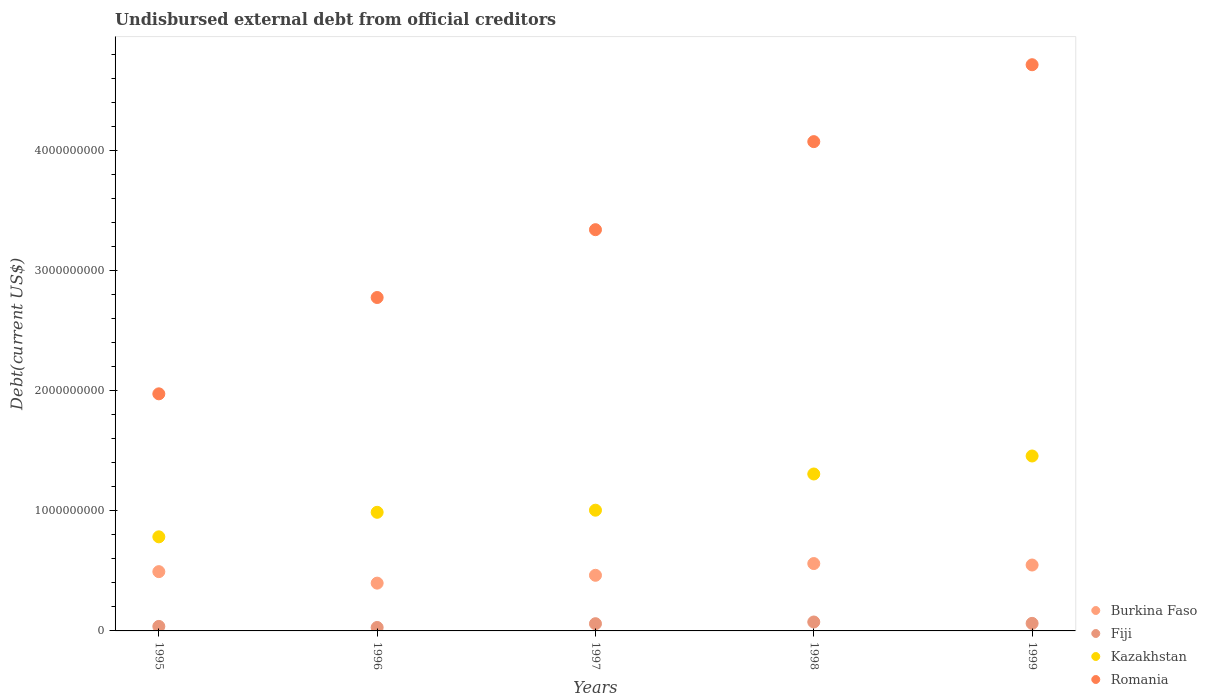How many different coloured dotlines are there?
Offer a very short reply. 4. What is the total debt in Kazakhstan in 1996?
Ensure brevity in your answer.  9.88e+08. Across all years, what is the maximum total debt in Kazakhstan?
Keep it short and to the point. 1.46e+09. Across all years, what is the minimum total debt in Kazakhstan?
Offer a terse response. 7.84e+08. In which year was the total debt in Romania minimum?
Your answer should be compact. 1995. What is the total total debt in Romania in the graph?
Your answer should be compact. 1.69e+1. What is the difference between the total debt in Romania in 1995 and that in 1996?
Keep it short and to the point. -8.02e+08. What is the difference between the total debt in Romania in 1998 and the total debt in Fiji in 1997?
Your response must be concise. 4.01e+09. What is the average total debt in Romania per year?
Make the answer very short. 3.38e+09. In the year 1997, what is the difference between the total debt in Kazakhstan and total debt in Burkina Faso?
Make the answer very short. 5.42e+08. What is the ratio of the total debt in Fiji in 1998 to that in 1999?
Your answer should be very brief. 1.18. Is the total debt in Kazakhstan in 1998 less than that in 1999?
Your answer should be compact. Yes. What is the difference between the highest and the second highest total debt in Romania?
Offer a terse response. 6.41e+08. What is the difference between the highest and the lowest total debt in Kazakhstan?
Your response must be concise. 6.73e+08. In how many years, is the total debt in Fiji greater than the average total debt in Fiji taken over all years?
Offer a very short reply. 3. Is it the case that in every year, the sum of the total debt in Romania and total debt in Fiji  is greater than the sum of total debt in Burkina Faso and total debt in Kazakhstan?
Keep it short and to the point. Yes. Does the total debt in Romania monotonically increase over the years?
Offer a very short reply. Yes. Is the total debt in Romania strictly less than the total debt in Kazakhstan over the years?
Keep it short and to the point. No. How many dotlines are there?
Make the answer very short. 4. How are the legend labels stacked?
Ensure brevity in your answer.  Vertical. What is the title of the graph?
Your response must be concise. Undisbursed external debt from official creditors. Does "Kiribati" appear as one of the legend labels in the graph?
Provide a succinct answer. No. What is the label or title of the X-axis?
Keep it short and to the point. Years. What is the label or title of the Y-axis?
Make the answer very short. Debt(current US$). What is the Debt(current US$) of Burkina Faso in 1995?
Your answer should be very brief. 4.94e+08. What is the Debt(current US$) in Fiji in 1995?
Your response must be concise. 3.75e+07. What is the Debt(current US$) of Kazakhstan in 1995?
Your answer should be compact. 7.84e+08. What is the Debt(current US$) of Romania in 1995?
Offer a very short reply. 1.97e+09. What is the Debt(current US$) of Burkina Faso in 1996?
Offer a terse response. 3.98e+08. What is the Debt(current US$) of Fiji in 1996?
Provide a succinct answer. 2.88e+07. What is the Debt(current US$) in Kazakhstan in 1996?
Make the answer very short. 9.88e+08. What is the Debt(current US$) in Romania in 1996?
Provide a short and direct response. 2.78e+09. What is the Debt(current US$) in Burkina Faso in 1997?
Your answer should be very brief. 4.63e+08. What is the Debt(current US$) of Fiji in 1997?
Offer a terse response. 6.01e+07. What is the Debt(current US$) of Kazakhstan in 1997?
Give a very brief answer. 1.01e+09. What is the Debt(current US$) in Romania in 1997?
Provide a succinct answer. 3.34e+09. What is the Debt(current US$) of Burkina Faso in 1998?
Your answer should be very brief. 5.61e+08. What is the Debt(current US$) of Fiji in 1998?
Your response must be concise. 7.43e+07. What is the Debt(current US$) in Kazakhstan in 1998?
Provide a short and direct response. 1.31e+09. What is the Debt(current US$) of Romania in 1998?
Your answer should be very brief. 4.07e+09. What is the Debt(current US$) of Burkina Faso in 1999?
Your answer should be compact. 5.49e+08. What is the Debt(current US$) in Fiji in 1999?
Provide a short and direct response. 6.29e+07. What is the Debt(current US$) in Kazakhstan in 1999?
Provide a short and direct response. 1.46e+09. What is the Debt(current US$) of Romania in 1999?
Your answer should be very brief. 4.72e+09. Across all years, what is the maximum Debt(current US$) of Burkina Faso?
Your answer should be very brief. 5.61e+08. Across all years, what is the maximum Debt(current US$) of Fiji?
Offer a very short reply. 7.43e+07. Across all years, what is the maximum Debt(current US$) in Kazakhstan?
Make the answer very short. 1.46e+09. Across all years, what is the maximum Debt(current US$) of Romania?
Ensure brevity in your answer.  4.72e+09. Across all years, what is the minimum Debt(current US$) in Burkina Faso?
Make the answer very short. 3.98e+08. Across all years, what is the minimum Debt(current US$) of Fiji?
Your response must be concise. 2.88e+07. Across all years, what is the minimum Debt(current US$) in Kazakhstan?
Offer a very short reply. 7.84e+08. Across all years, what is the minimum Debt(current US$) in Romania?
Your answer should be compact. 1.97e+09. What is the total Debt(current US$) in Burkina Faso in the graph?
Give a very brief answer. 2.46e+09. What is the total Debt(current US$) in Fiji in the graph?
Ensure brevity in your answer.  2.64e+08. What is the total Debt(current US$) in Kazakhstan in the graph?
Provide a succinct answer. 5.54e+09. What is the total Debt(current US$) in Romania in the graph?
Provide a succinct answer. 1.69e+1. What is the difference between the Debt(current US$) in Burkina Faso in 1995 and that in 1996?
Provide a short and direct response. 9.57e+07. What is the difference between the Debt(current US$) of Fiji in 1995 and that in 1996?
Give a very brief answer. 8.80e+06. What is the difference between the Debt(current US$) in Kazakhstan in 1995 and that in 1996?
Provide a short and direct response. -2.04e+08. What is the difference between the Debt(current US$) in Romania in 1995 and that in 1996?
Make the answer very short. -8.02e+08. What is the difference between the Debt(current US$) in Burkina Faso in 1995 and that in 1997?
Provide a short and direct response. 3.04e+07. What is the difference between the Debt(current US$) of Fiji in 1995 and that in 1997?
Your response must be concise. -2.26e+07. What is the difference between the Debt(current US$) in Kazakhstan in 1995 and that in 1997?
Offer a terse response. -2.22e+08. What is the difference between the Debt(current US$) of Romania in 1995 and that in 1997?
Provide a succinct answer. -1.37e+09. What is the difference between the Debt(current US$) of Burkina Faso in 1995 and that in 1998?
Keep it short and to the point. -6.73e+07. What is the difference between the Debt(current US$) of Fiji in 1995 and that in 1998?
Give a very brief answer. -3.68e+07. What is the difference between the Debt(current US$) of Kazakhstan in 1995 and that in 1998?
Ensure brevity in your answer.  -5.23e+08. What is the difference between the Debt(current US$) of Romania in 1995 and that in 1998?
Provide a succinct answer. -2.10e+09. What is the difference between the Debt(current US$) of Burkina Faso in 1995 and that in 1999?
Make the answer very short. -5.50e+07. What is the difference between the Debt(current US$) in Fiji in 1995 and that in 1999?
Provide a short and direct response. -2.53e+07. What is the difference between the Debt(current US$) of Kazakhstan in 1995 and that in 1999?
Ensure brevity in your answer.  -6.73e+08. What is the difference between the Debt(current US$) in Romania in 1995 and that in 1999?
Provide a succinct answer. -2.74e+09. What is the difference between the Debt(current US$) of Burkina Faso in 1996 and that in 1997?
Your answer should be very brief. -6.53e+07. What is the difference between the Debt(current US$) in Fiji in 1996 and that in 1997?
Make the answer very short. -3.14e+07. What is the difference between the Debt(current US$) in Kazakhstan in 1996 and that in 1997?
Provide a short and direct response. -1.75e+07. What is the difference between the Debt(current US$) in Romania in 1996 and that in 1997?
Make the answer very short. -5.65e+08. What is the difference between the Debt(current US$) of Burkina Faso in 1996 and that in 1998?
Provide a short and direct response. -1.63e+08. What is the difference between the Debt(current US$) of Fiji in 1996 and that in 1998?
Provide a succinct answer. -4.56e+07. What is the difference between the Debt(current US$) of Kazakhstan in 1996 and that in 1998?
Provide a succinct answer. -3.19e+08. What is the difference between the Debt(current US$) of Romania in 1996 and that in 1998?
Ensure brevity in your answer.  -1.30e+09. What is the difference between the Debt(current US$) of Burkina Faso in 1996 and that in 1999?
Your answer should be compact. -1.51e+08. What is the difference between the Debt(current US$) of Fiji in 1996 and that in 1999?
Ensure brevity in your answer.  -3.41e+07. What is the difference between the Debt(current US$) in Kazakhstan in 1996 and that in 1999?
Ensure brevity in your answer.  -4.69e+08. What is the difference between the Debt(current US$) in Romania in 1996 and that in 1999?
Keep it short and to the point. -1.94e+09. What is the difference between the Debt(current US$) in Burkina Faso in 1997 and that in 1998?
Your answer should be compact. -9.77e+07. What is the difference between the Debt(current US$) of Fiji in 1997 and that in 1998?
Offer a very short reply. -1.42e+07. What is the difference between the Debt(current US$) of Kazakhstan in 1997 and that in 1998?
Make the answer very short. -3.02e+08. What is the difference between the Debt(current US$) in Romania in 1997 and that in 1998?
Provide a succinct answer. -7.33e+08. What is the difference between the Debt(current US$) of Burkina Faso in 1997 and that in 1999?
Make the answer very short. -8.54e+07. What is the difference between the Debt(current US$) of Fiji in 1997 and that in 1999?
Ensure brevity in your answer.  -2.77e+06. What is the difference between the Debt(current US$) of Kazakhstan in 1997 and that in 1999?
Keep it short and to the point. -4.51e+08. What is the difference between the Debt(current US$) of Romania in 1997 and that in 1999?
Give a very brief answer. -1.37e+09. What is the difference between the Debt(current US$) in Burkina Faso in 1998 and that in 1999?
Keep it short and to the point. 1.23e+07. What is the difference between the Debt(current US$) in Fiji in 1998 and that in 1999?
Your answer should be very brief. 1.14e+07. What is the difference between the Debt(current US$) in Kazakhstan in 1998 and that in 1999?
Give a very brief answer. -1.50e+08. What is the difference between the Debt(current US$) of Romania in 1998 and that in 1999?
Offer a terse response. -6.41e+08. What is the difference between the Debt(current US$) in Burkina Faso in 1995 and the Debt(current US$) in Fiji in 1996?
Ensure brevity in your answer.  4.65e+08. What is the difference between the Debt(current US$) of Burkina Faso in 1995 and the Debt(current US$) of Kazakhstan in 1996?
Your answer should be very brief. -4.94e+08. What is the difference between the Debt(current US$) in Burkina Faso in 1995 and the Debt(current US$) in Romania in 1996?
Offer a terse response. -2.28e+09. What is the difference between the Debt(current US$) of Fiji in 1995 and the Debt(current US$) of Kazakhstan in 1996?
Your response must be concise. -9.50e+08. What is the difference between the Debt(current US$) of Fiji in 1995 and the Debt(current US$) of Romania in 1996?
Provide a short and direct response. -2.74e+09. What is the difference between the Debt(current US$) of Kazakhstan in 1995 and the Debt(current US$) of Romania in 1996?
Your answer should be very brief. -1.99e+09. What is the difference between the Debt(current US$) in Burkina Faso in 1995 and the Debt(current US$) in Fiji in 1997?
Ensure brevity in your answer.  4.34e+08. What is the difference between the Debt(current US$) in Burkina Faso in 1995 and the Debt(current US$) in Kazakhstan in 1997?
Make the answer very short. -5.12e+08. What is the difference between the Debt(current US$) of Burkina Faso in 1995 and the Debt(current US$) of Romania in 1997?
Ensure brevity in your answer.  -2.85e+09. What is the difference between the Debt(current US$) of Fiji in 1995 and the Debt(current US$) of Kazakhstan in 1997?
Keep it short and to the point. -9.68e+08. What is the difference between the Debt(current US$) of Fiji in 1995 and the Debt(current US$) of Romania in 1997?
Your response must be concise. -3.30e+09. What is the difference between the Debt(current US$) in Kazakhstan in 1995 and the Debt(current US$) in Romania in 1997?
Give a very brief answer. -2.56e+09. What is the difference between the Debt(current US$) of Burkina Faso in 1995 and the Debt(current US$) of Fiji in 1998?
Your response must be concise. 4.19e+08. What is the difference between the Debt(current US$) in Burkina Faso in 1995 and the Debt(current US$) in Kazakhstan in 1998?
Your answer should be compact. -8.13e+08. What is the difference between the Debt(current US$) of Burkina Faso in 1995 and the Debt(current US$) of Romania in 1998?
Your answer should be very brief. -3.58e+09. What is the difference between the Debt(current US$) of Fiji in 1995 and the Debt(current US$) of Kazakhstan in 1998?
Provide a short and direct response. -1.27e+09. What is the difference between the Debt(current US$) in Fiji in 1995 and the Debt(current US$) in Romania in 1998?
Keep it short and to the point. -4.04e+09. What is the difference between the Debt(current US$) in Kazakhstan in 1995 and the Debt(current US$) in Romania in 1998?
Your response must be concise. -3.29e+09. What is the difference between the Debt(current US$) of Burkina Faso in 1995 and the Debt(current US$) of Fiji in 1999?
Your answer should be compact. 4.31e+08. What is the difference between the Debt(current US$) of Burkina Faso in 1995 and the Debt(current US$) of Kazakhstan in 1999?
Make the answer very short. -9.63e+08. What is the difference between the Debt(current US$) in Burkina Faso in 1995 and the Debt(current US$) in Romania in 1999?
Your response must be concise. -4.22e+09. What is the difference between the Debt(current US$) in Fiji in 1995 and the Debt(current US$) in Kazakhstan in 1999?
Your answer should be very brief. -1.42e+09. What is the difference between the Debt(current US$) in Fiji in 1995 and the Debt(current US$) in Romania in 1999?
Your answer should be very brief. -4.68e+09. What is the difference between the Debt(current US$) of Kazakhstan in 1995 and the Debt(current US$) of Romania in 1999?
Ensure brevity in your answer.  -3.93e+09. What is the difference between the Debt(current US$) of Burkina Faso in 1996 and the Debt(current US$) of Fiji in 1997?
Ensure brevity in your answer.  3.38e+08. What is the difference between the Debt(current US$) of Burkina Faso in 1996 and the Debt(current US$) of Kazakhstan in 1997?
Give a very brief answer. -6.07e+08. What is the difference between the Debt(current US$) in Burkina Faso in 1996 and the Debt(current US$) in Romania in 1997?
Your response must be concise. -2.94e+09. What is the difference between the Debt(current US$) of Fiji in 1996 and the Debt(current US$) of Kazakhstan in 1997?
Keep it short and to the point. -9.77e+08. What is the difference between the Debt(current US$) of Fiji in 1996 and the Debt(current US$) of Romania in 1997?
Provide a short and direct response. -3.31e+09. What is the difference between the Debt(current US$) in Kazakhstan in 1996 and the Debt(current US$) in Romania in 1997?
Your answer should be very brief. -2.35e+09. What is the difference between the Debt(current US$) in Burkina Faso in 1996 and the Debt(current US$) in Fiji in 1998?
Provide a short and direct response. 3.24e+08. What is the difference between the Debt(current US$) in Burkina Faso in 1996 and the Debt(current US$) in Kazakhstan in 1998?
Your answer should be very brief. -9.09e+08. What is the difference between the Debt(current US$) in Burkina Faso in 1996 and the Debt(current US$) in Romania in 1998?
Your response must be concise. -3.68e+09. What is the difference between the Debt(current US$) of Fiji in 1996 and the Debt(current US$) of Kazakhstan in 1998?
Your answer should be very brief. -1.28e+09. What is the difference between the Debt(current US$) in Fiji in 1996 and the Debt(current US$) in Romania in 1998?
Provide a short and direct response. -4.05e+09. What is the difference between the Debt(current US$) of Kazakhstan in 1996 and the Debt(current US$) of Romania in 1998?
Ensure brevity in your answer.  -3.09e+09. What is the difference between the Debt(current US$) of Burkina Faso in 1996 and the Debt(current US$) of Fiji in 1999?
Ensure brevity in your answer.  3.35e+08. What is the difference between the Debt(current US$) in Burkina Faso in 1996 and the Debt(current US$) in Kazakhstan in 1999?
Your response must be concise. -1.06e+09. What is the difference between the Debt(current US$) of Burkina Faso in 1996 and the Debt(current US$) of Romania in 1999?
Your answer should be compact. -4.32e+09. What is the difference between the Debt(current US$) in Fiji in 1996 and the Debt(current US$) in Kazakhstan in 1999?
Make the answer very short. -1.43e+09. What is the difference between the Debt(current US$) in Fiji in 1996 and the Debt(current US$) in Romania in 1999?
Your answer should be very brief. -4.69e+09. What is the difference between the Debt(current US$) of Kazakhstan in 1996 and the Debt(current US$) of Romania in 1999?
Offer a terse response. -3.73e+09. What is the difference between the Debt(current US$) in Burkina Faso in 1997 and the Debt(current US$) in Fiji in 1998?
Provide a short and direct response. 3.89e+08. What is the difference between the Debt(current US$) of Burkina Faso in 1997 and the Debt(current US$) of Kazakhstan in 1998?
Your response must be concise. -8.44e+08. What is the difference between the Debt(current US$) of Burkina Faso in 1997 and the Debt(current US$) of Romania in 1998?
Your answer should be compact. -3.61e+09. What is the difference between the Debt(current US$) in Fiji in 1997 and the Debt(current US$) in Kazakhstan in 1998?
Your answer should be compact. -1.25e+09. What is the difference between the Debt(current US$) of Fiji in 1997 and the Debt(current US$) of Romania in 1998?
Keep it short and to the point. -4.01e+09. What is the difference between the Debt(current US$) of Kazakhstan in 1997 and the Debt(current US$) of Romania in 1998?
Your answer should be compact. -3.07e+09. What is the difference between the Debt(current US$) in Burkina Faso in 1997 and the Debt(current US$) in Fiji in 1999?
Give a very brief answer. 4.00e+08. What is the difference between the Debt(current US$) in Burkina Faso in 1997 and the Debt(current US$) in Kazakhstan in 1999?
Offer a terse response. -9.94e+08. What is the difference between the Debt(current US$) in Burkina Faso in 1997 and the Debt(current US$) in Romania in 1999?
Your answer should be very brief. -4.25e+09. What is the difference between the Debt(current US$) in Fiji in 1997 and the Debt(current US$) in Kazakhstan in 1999?
Provide a succinct answer. -1.40e+09. What is the difference between the Debt(current US$) in Fiji in 1997 and the Debt(current US$) in Romania in 1999?
Offer a very short reply. -4.66e+09. What is the difference between the Debt(current US$) in Kazakhstan in 1997 and the Debt(current US$) in Romania in 1999?
Offer a very short reply. -3.71e+09. What is the difference between the Debt(current US$) of Burkina Faso in 1998 and the Debt(current US$) of Fiji in 1999?
Offer a terse response. 4.98e+08. What is the difference between the Debt(current US$) of Burkina Faso in 1998 and the Debt(current US$) of Kazakhstan in 1999?
Your answer should be very brief. -8.96e+08. What is the difference between the Debt(current US$) in Burkina Faso in 1998 and the Debt(current US$) in Romania in 1999?
Give a very brief answer. -4.15e+09. What is the difference between the Debt(current US$) of Fiji in 1998 and the Debt(current US$) of Kazakhstan in 1999?
Make the answer very short. -1.38e+09. What is the difference between the Debt(current US$) in Fiji in 1998 and the Debt(current US$) in Romania in 1999?
Provide a succinct answer. -4.64e+09. What is the difference between the Debt(current US$) of Kazakhstan in 1998 and the Debt(current US$) of Romania in 1999?
Your answer should be very brief. -3.41e+09. What is the average Debt(current US$) in Burkina Faso per year?
Your answer should be very brief. 4.93e+08. What is the average Debt(current US$) of Fiji per year?
Provide a short and direct response. 5.27e+07. What is the average Debt(current US$) of Kazakhstan per year?
Ensure brevity in your answer.  1.11e+09. What is the average Debt(current US$) in Romania per year?
Keep it short and to the point. 3.38e+09. In the year 1995, what is the difference between the Debt(current US$) in Burkina Faso and Debt(current US$) in Fiji?
Keep it short and to the point. 4.56e+08. In the year 1995, what is the difference between the Debt(current US$) in Burkina Faso and Debt(current US$) in Kazakhstan?
Your response must be concise. -2.90e+08. In the year 1995, what is the difference between the Debt(current US$) in Burkina Faso and Debt(current US$) in Romania?
Provide a short and direct response. -1.48e+09. In the year 1995, what is the difference between the Debt(current US$) of Fiji and Debt(current US$) of Kazakhstan?
Make the answer very short. -7.46e+08. In the year 1995, what is the difference between the Debt(current US$) in Fiji and Debt(current US$) in Romania?
Provide a short and direct response. -1.94e+09. In the year 1995, what is the difference between the Debt(current US$) in Kazakhstan and Debt(current US$) in Romania?
Your answer should be very brief. -1.19e+09. In the year 1996, what is the difference between the Debt(current US$) of Burkina Faso and Debt(current US$) of Fiji?
Keep it short and to the point. 3.69e+08. In the year 1996, what is the difference between the Debt(current US$) in Burkina Faso and Debt(current US$) in Kazakhstan?
Keep it short and to the point. -5.90e+08. In the year 1996, what is the difference between the Debt(current US$) of Burkina Faso and Debt(current US$) of Romania?
Give a very brief answer. -2.38e+09. In the year 1996, what is the difference between the Debt(current US$) in Fiji and Debt(current US$) in Kazakhstan?
Give a very brief answer. -9.59e+08. In the year 1996, what is the difference between the Debt(current US$) in Fiji and Debt(current US$) in Romania?
Offer a very short reply. -2.75e+09. In the year 1996, what is the difference between the Debt(current US$) in Kazakhstan and Debt(current US$) in Romania?
Your answer should be compact. -1.79e+09. In the year 1997, what is the difference between the Debt(current US$) in Burkina Faso and Debt(current US$) in Fiji?
Offer a terse response. 4.03e+08. In the year 1997, what is the difference between the Debt(current US$) in Burkina Faso and Debt(current US$) in Kazakhstan?
Your answer should be compact. -5.42e+08. In the year 1997, what is the difference between the Debt(current US$) of Burkina Faso and Debt(current US$) of Romania?
Offer a terse response. -2.88e+09. In the year 1997, what is the difference between the Debt(current US$) of Fiji and Debt(current US$) of Kazakhstan?
Give a very brief answer. -9.45e+08. In the year 1997, what is the difference between the Debt(current US$) in Fiji and Debt(current US$) in Romania?
Provide a succinct answer. -3.28e+09. In the year 1997, what is the difference between the Debt(current US$) of Kazakhstan and Debt(current US$) of Romania?
Your response must be concise. -2.34e+09. In the year 1998, what is the difference between the Debt(current US$) in Burkina Faso and Debt(current US$) in Fiji?
Offer a very short reply. 4.87e+08. In the year 1998, what is the difference between the Debt(current US$) in Burkina Faso and Debt(current US$) in Kazakhstan?
Ensure brevity in your answer.  -7.46e+08. In the year 1998, what is the difference between the Debt(current US$) of Burkina Faso and Debt(current US$) of Romania?
Make the answer very short. -3.51e+09. In the year 1998, what is the difference between the Debt(current US$) in Fiji and Debt(current US$) in Kazakhstan?
Make the answer very short. -1.23e+09. In the year 1998, what is the difference between the Debt(current US$) in Fiji and Debt(current US$) in Romania?
Provide a short and direct response. -4.00e+09. In the year 1998, what is the difference between the Debt(current US$) in Kazakhstan and Debt(current US$) in Romania?
Offer a terse response. -2.77e+09. In the year 1999, what is the difference between the Debt(current US$) in Burkina Faso and Debt(current US$) in Fiji?
Offer a very short reply. 4.86e+08. In the year 1999, what is the difference between the Debt(current US$) in Burkina Faso and Debt(current US$) in Kazakhstan?
Your answer should be compact. -9.08e+08. In the year 1999, what is the difference between the Debt(current US$) of Burkina Faso and Debt(current US$) of Romania?
Provide a succinct answer. -4.17e+09. In the year 1999, what is the difference between the Debt(current US$) of Fiji and Debt(current US$) of Kazakhstan?
Provide a succinct answer. -1.39e+09. In the year 1999, what is the difference between the Debt(current US$) of Fiji and Debt(current US$) of Romania?
Give a very brief answer. -4.65e+09. In the year 1999, what is the difference between the Debt(current US$) of Kazakhstan and Debt(current US$) of Romania?
Offer a very short reply. -3.26e+09. What is the ratio of the Debt(current US$) of Burkina Faso in 1995 to that in 1996?
Your response must be concise. 1.24. What is the ratio of the Debt(current US$) in Fiji in 1995 to that in 1996?
Give a very brief answer. 1.31. What is the ratio of the Debt(current US$) in Kazakhstan in 1995 to that in 1996?
Offer a very short reply. 0.79. What is the ratio of the Debt(current US$) of Romania in 1995 to that in 1996?
Your answer should be compact. 0.71. What is the ratio of the Debt(current US$) of Burkina Faso in 1995 to that in 1997?
Your answer should be very brief. 1.07. What is the ratio of the Debt(current US$) of Fiji in 1995 to that in 1997?
Your answer should be very brief. 0.62. What is the ratio of the Debt(current US$) in Kazakhstan in 1995 to that in 1997?
Provide a succinct answer. 0.78. What is the ratio of the Debt(current US$) of Romania in 1995 to that in 1997?
Your response must be concise. 0.59. What is the ratio of the Debt(current US$) in Burkina Faso in 1995 to that in 1998?
Provide a short and direct response. 0.88. What is the ratio of the Debt(current US$) of Fiji in 1995 to that in 1998?
Offer a terse response. 0.51. What is the ratio of the Debt(current US$) of Kazakhstan in 1995 to that in 1998?
Ensure brevity in your answer.  0.6. What is the ratio of the Debt(current US$) of Romania in 1995 to that in 1998?
Your answer should be compact. 0.48. What is the ratio of the Debt(current US$) in Burkina Faso in 1995 to that in 1999?
Give a very brief answer. 0.9. What is the ratio of the Debt(current US$) in Fiji in 1995 to that in 1999?
Give a very brief answer. 0.6. What is the ratio of the Debt(current US$) of Kazakhstan in 1995 to that in 1999?
Your answer should be very brief. 0.54. What is the ratio of the Debt(current US$) of Romania in 1995 to that in 1999?
Offer a terse response. 0.42. What is the ratio of the Debt(current US$) in Burkina Faso in 1996 to that in 1997?
Offer a very short reply. 0.86. What is the ratio of the Debt(current US$) in Fiji in 1996 to that in 1997?
Make the answer very short. 0.48. What is the ratio of the Debt(current US$) of Kazakhstan in 1996 to that in 1997?
Your answer should be very brief. 0.98. What is the ratio of the Debt(current US$) of Romania in 1996 to that in 1997?
Provide a short and direct response. 0.83. What is the ratio of the Debt(current US$) of Burkina Faso in 1996 to that in 1998?
Ensure brevity in your answer.  0.71. What is the ratio of the Debt(current US$) in Fiji in 1996 to that in 1998?
Provide a succinct answer. 0.39. What is the ratio of the Debt(current US$) in Kazakhstan in 1996 to that in 1998?
Provide a short and direct response. 0.76. What is the ratio of the Debt(current US$) in Romania in 1996 to that in 1998?
Ensure brevity in your answer.  0.68. What is the ratio of the Debt(current US$) of Burkina Faso in 1996 to that in 1999?
Your answer should be compact. 0.73. What is the ratio of the Debt(current US$) in Fiji in 1996 to that in 1999?
Your answer should be compact. 0.46. What is the ratio of the Debt(current US$) of Kazakhstan in 1996 to that in 1999?
Give a very brief answer. 0.68. What is the ratio of the Debt(current US$) in Romania in 1996 to that in 1999?
Give a very brief answer. 0.59. What is the ratio of the Debt(current US$) of Burkina Faso in 1997 to that in 1998?
Your response must be concise. 0.83. What is the ratio of the Debt(current US$) in Fiji in 1997 to that in 1998?
Your answer should be compact. 0.81. What is the ratio of the Debt(current US$) in Kazakhstan in 1997 to that in 1998?
Your answer should be compact. 0.77. What is the ratio of the Debt(current US$) of Romania in 1997 to that in 1998?
Offer a very short reply. 0.82. What is the ratio of the Debt(current US$) of Burkina Faso in 1997 to that in 1999?
Your answer should be compact. 0.84. What is the ratio of the Debt(current US$) in Fiji in 1997 to that in 1999?
Offer a very short reply. 0.96. What is the ratio of the Debt(current US$) of Kazakhstan in 1997 to that in 1999?
Provide a succinct answer. 0.69. What is the ratio of the Debt(current US$) in Romania in 1997 to that in 1999?
Offer a very short reply. 0.71. What is the ratio of the Debt(current US$) in Burkina Faso in 1998 to that in 1999?
Give a very brief answer. 1.02. What is the ratio of the Debt(current US$) of Fiji in 1998 to that in 1999?
Provide a short and direct response. 1.18. What is the ratio of the Debt(current US$) in Kazakhstan in 1998 to that in 1999?
Your answer should be compact. 0.9. What is the ratio of the Debt(current US$) of Romania in 1998 to that in 1999?
Provide a succinct answer. 0.86. What is the difference between the highest and the second highest Debt(current US$) of Burkina Faso?
Your response must be concise. 1.23e+07. What is the difference between the highest and the second highest Debt(current US$) in Fiji?
Your answer should be very brief. 1.14e+07. What is the difference between the highest and the second highest Debt(current US$) in Kazakhstan?
Give a very brief answer. 1.50e+08. What is the difference between the highest and the second highest Debt(current US$) in Romania?
Offer a very short reply. 6.41e+08. What is the difference between the highest and the lowest Debt(current US$) in Burkina Faso?
Offer a terse response. 1.63e+08. What is the difference between the highest and the lowest Debt(current US$) of Fiji?
Provide a short and direct response. 4.56e+07. What is the difference between the highest and the lowest Debt(current US$) of Kazakhstan?
Your response must be concise. 6.73e+08. What is the difference between the highest and the lowest Debt(current US$) of Romania?
Provide a short and direct response. 2.74e+09. 